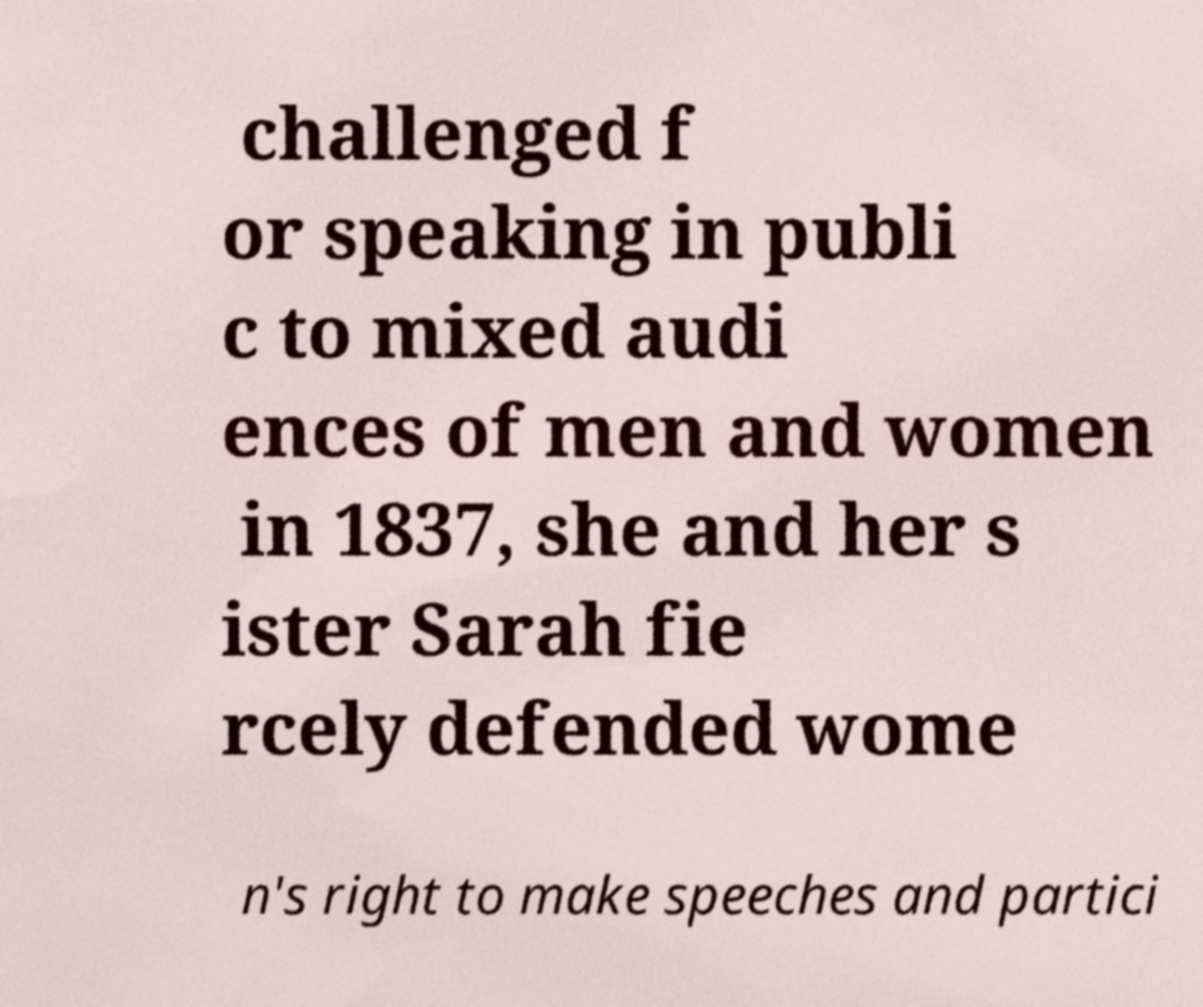There's text embedded in this image that I need extracted. Can you transcribe it verbatim? challenged f or speaking in publi c to mixed audi ences of men and women in 1837, she and her s ister Sarah fie rcely defended wome n's right to make speeches and partici 